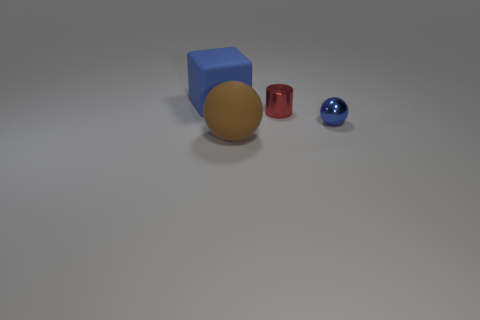Add 1 tiny spheres. How many objects exist? 5 Subtract all cylinders. How many objects are left? 3 Add 1 tiny objects. How many tiny objects are left? 3 Add 3 tiny purple rubber cylinders. How many tiny purple rubber cylinders exist? 3 Subtract 0 blue cylinders. How many objects are left? 4 Subtract 1 cylinders. How many cylinders are left? 0 Subtract all brown spheres. Subtract all yellow cylinders. How many spheres are left? 1 Subtract all purple cubes. How many brown spheres are left? 1 Subtract all green metallic cylinders. Subtract all brown balls. How many objects are left? 3 